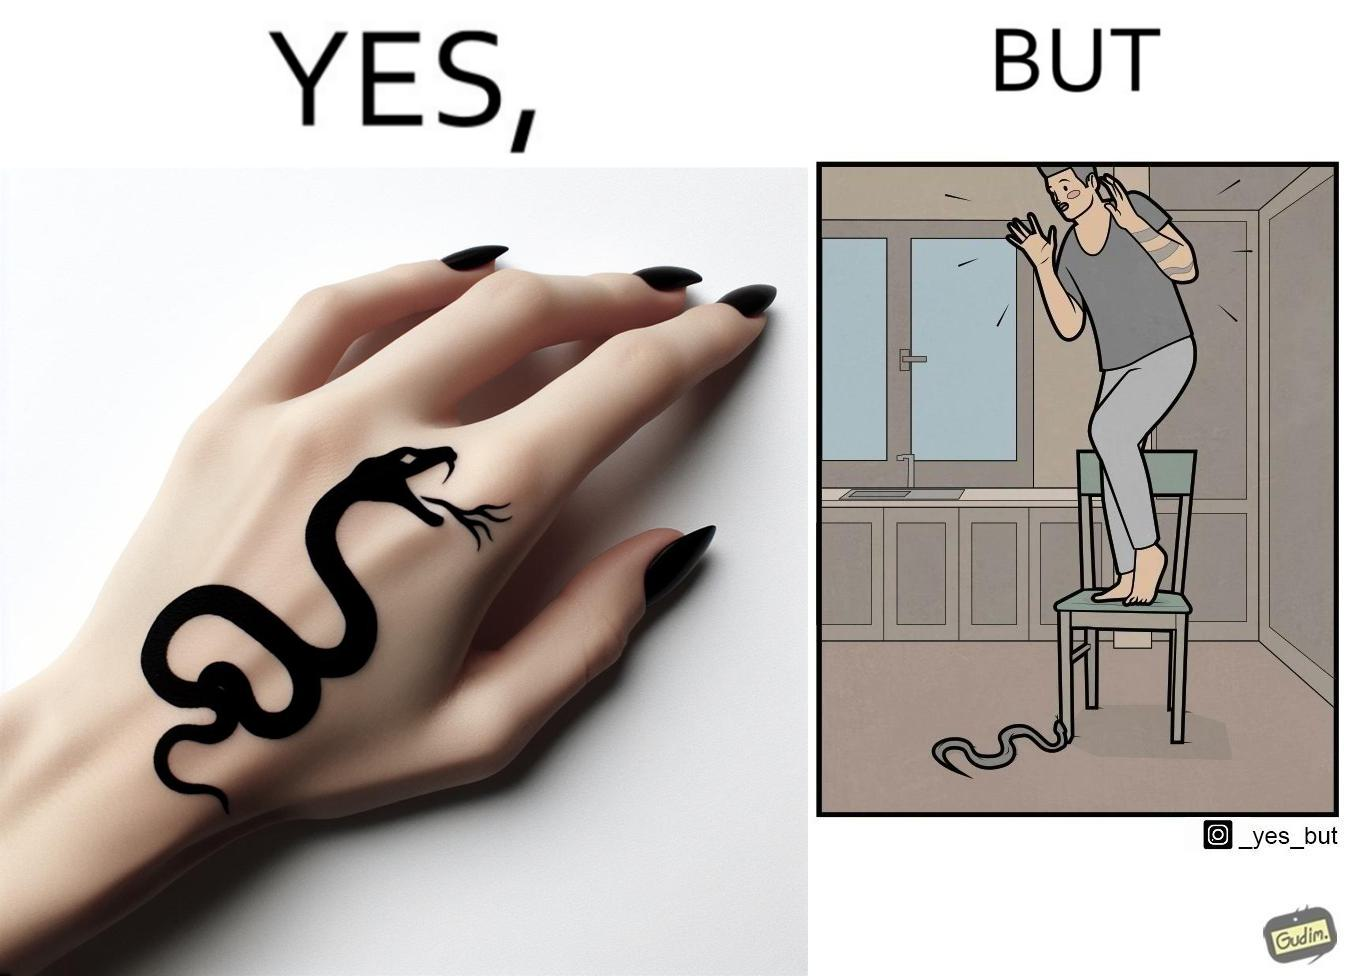Is this image satirical or non-satirical? Yes, this image is satirical. 